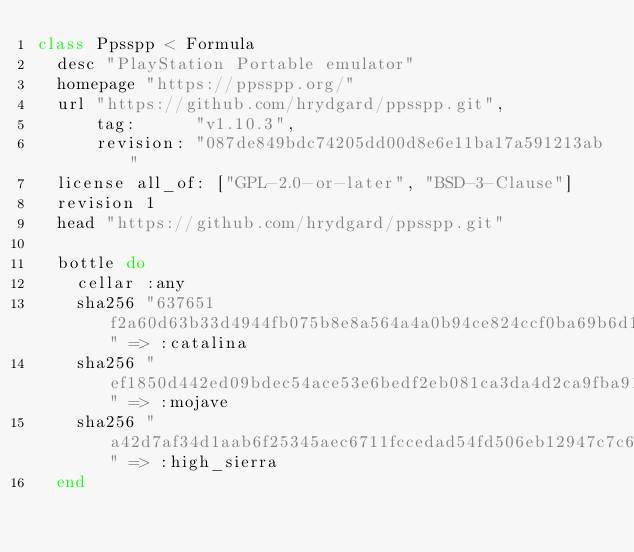<code> <loc_0><loc_0><loc_500><loc_500><_Ruby_>class Ppsspp < Formula
  desc "PlayStation Portable emulator"
  homepage "https://ppsspp.org/"
  url "https://github.com/hrydgard/ppsspp.git",
      tag:      "v1.10.3",
      revision: "087de849bdc74205dd00d8e6e11ba17a591213ab"
  license all_of: ["GPL-2.0-or-later", "BSD-3-Clause"]
  revision 1
  head "https://github.com/hrydgard/ppsspp.git"

  bottle do
    cellar :any
    sha256 "637651f2a60d63b33d4944fb075b8e8a564a4a0b94ce824ccf0ba69b6d101f88" => :catalina
    sha256 "ef1850d442ed09bdec54ace53e6bedf2eb081ca3da4d2ca9fba91293a98f0f6e" => :mojave
    sha256 "a42d7af34d1aab6f25345aec6711fccedad54fd506eb12947c7c6c8b7e095a55" => :high_sierra
  end
</code> 